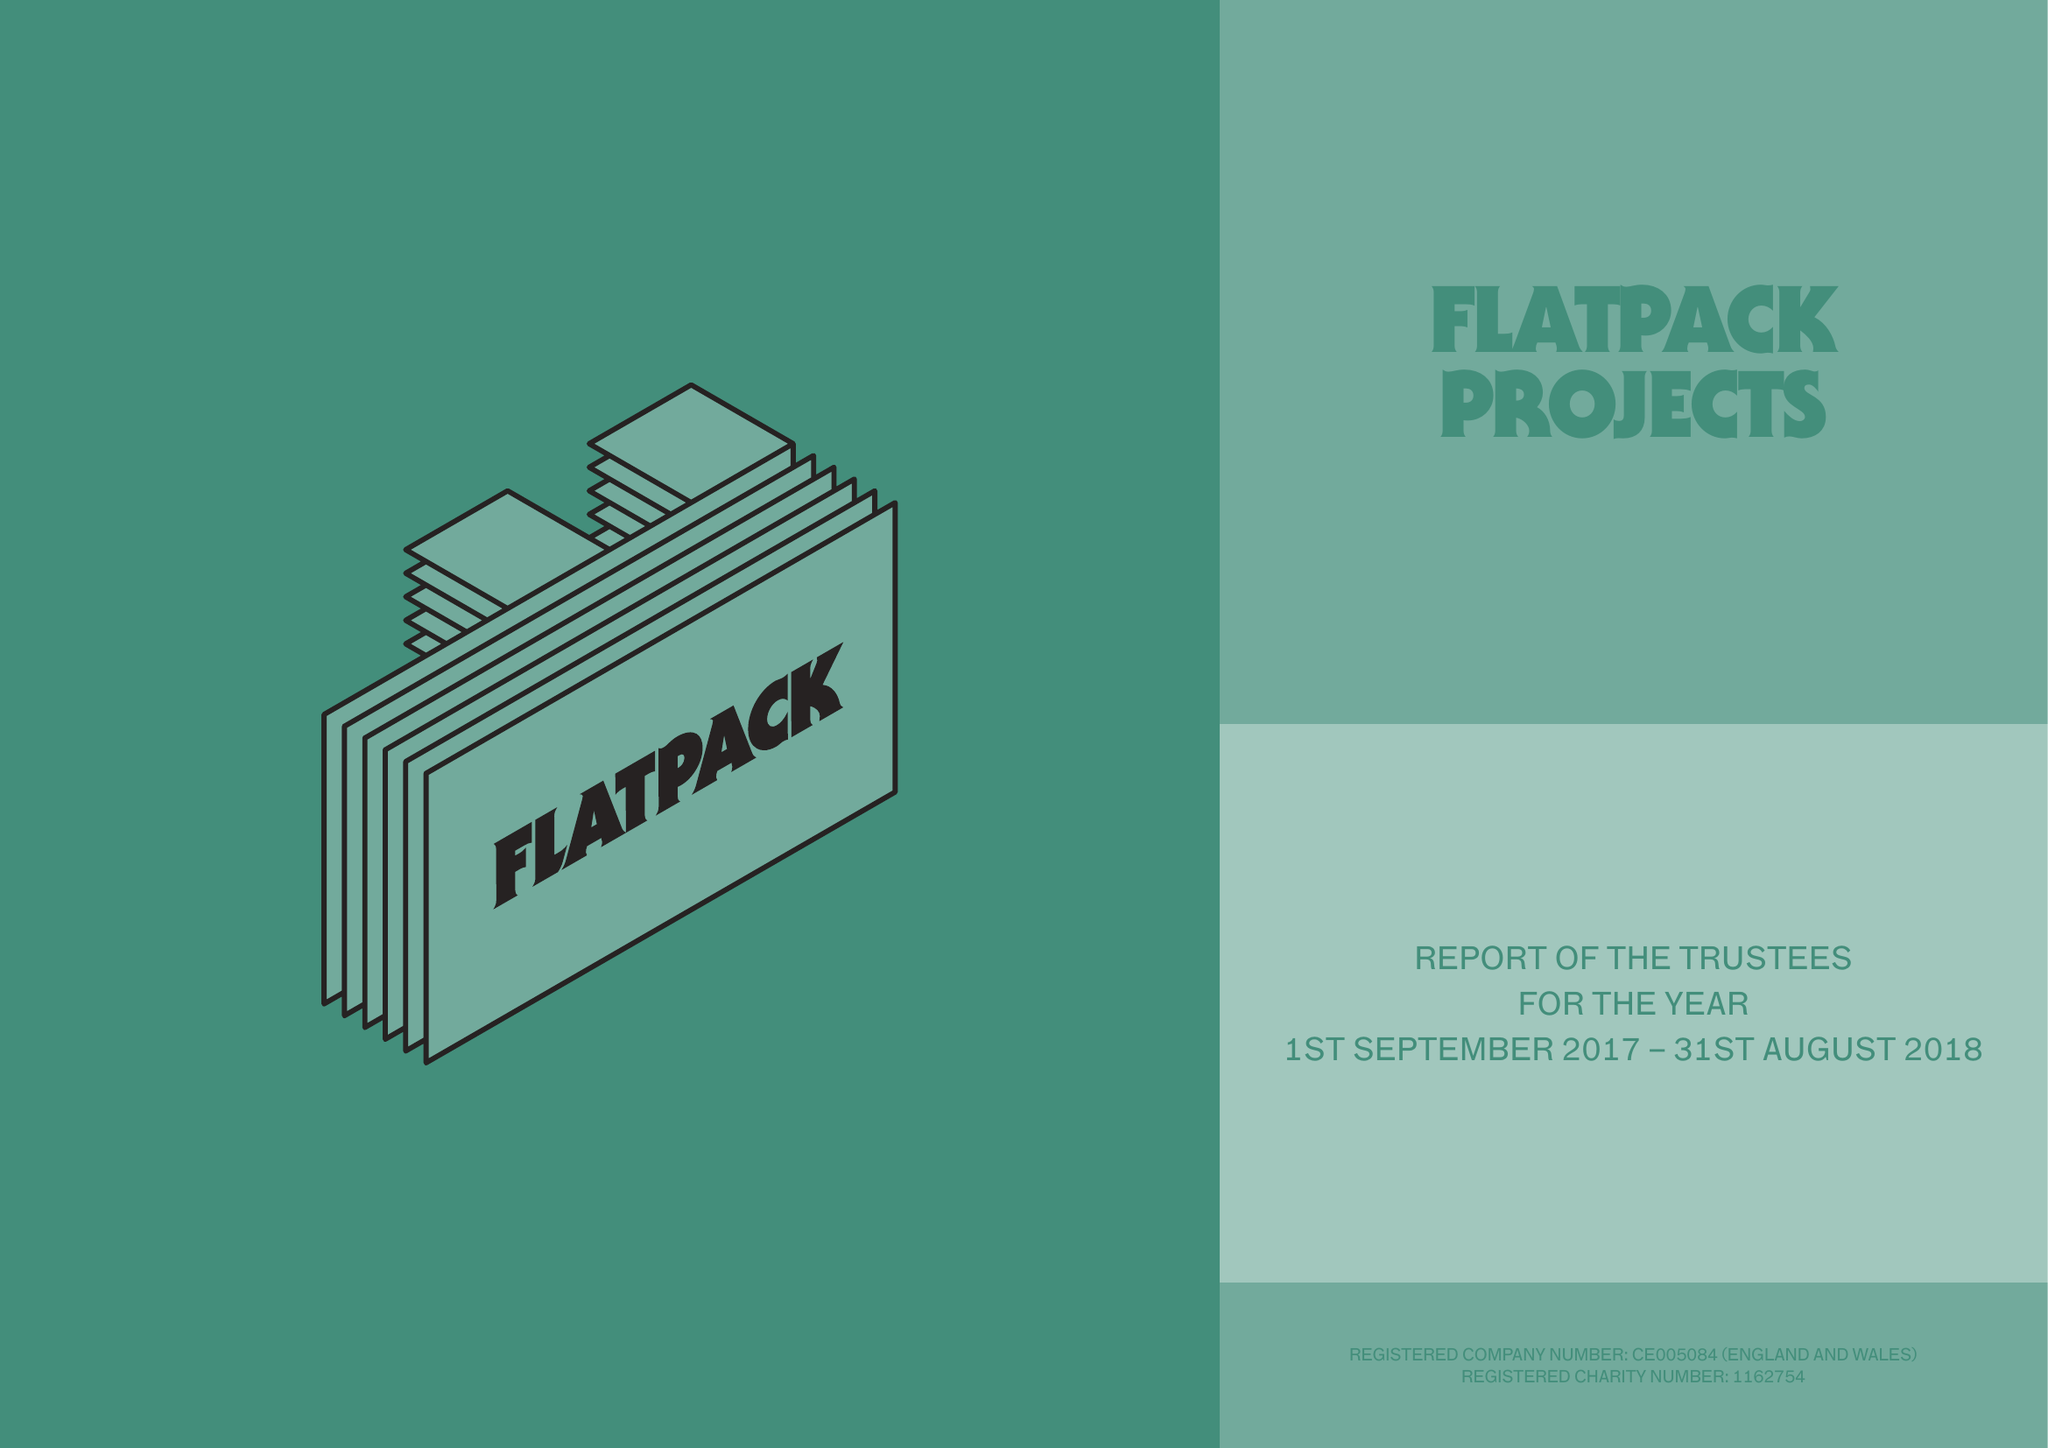What is the value for the income_annually_in_british_pounds?
Answer the question using a single word or phrase. 437697.00 